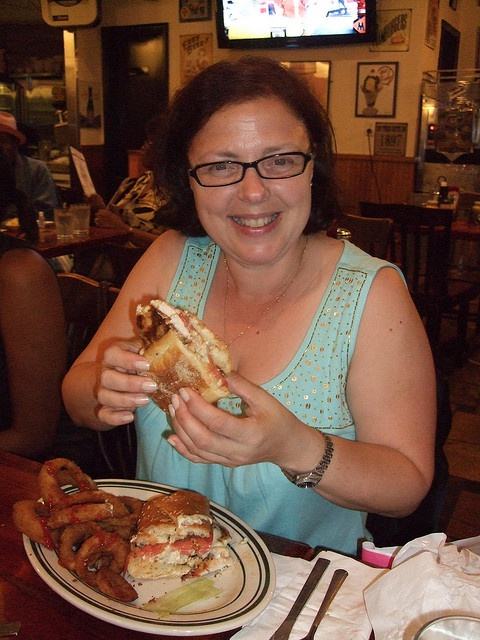Describe the objects in this image and their specific colors. I can see people in black, brown, and tan tones, dining table in black, maroon, and tan tones, people in black, maroon, and brown tones, chair in black, maroon, and gray tones, and sandwich in black, brown, maroon, and tan tones in this image. 